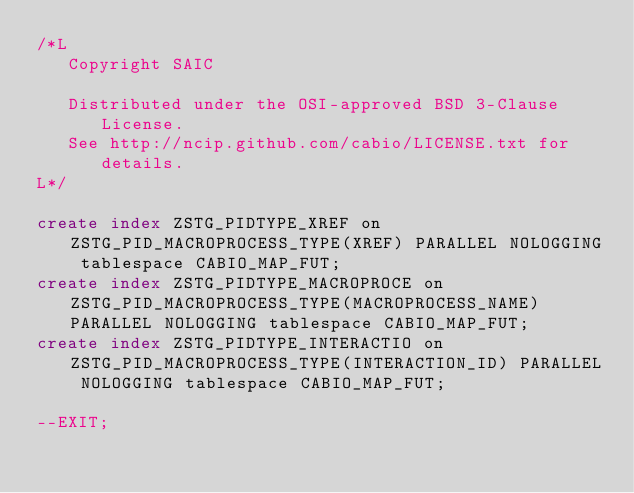Convert code to text. <code><loc_0><loc_0><loc_500><loc_500><_SQL_>/*L
   Copyright SAIC

   Distributed under the OSI-approved BSD 3-Clause License.
   See http://ncip.github.com/cabio/LICENSE.txt for details.
L*/

create index ZSTG_PIDTYPE_XREF on ZSTG_PID_MACROPROCESS_TYPE(XREF) PARALLEL NOLOGGING tablespace CABIO_MAP_FUT;
create index ZSTG_PIDTYPE_MACROPROCE on ZSTG_PID_MACROPROCESS_TYPE(MACROPROCESS_NAME) PARALLEL NOLOGGING tablespace CABIO_MAP_FUT;
create index ZSTG_PIDTYPE_INTERACTIO on ZSTG_PID_MACROPROCESS_TYPE(INTERACTION_ID) PARALLEL NOLOGGING tablespace CABIO_MAP_FUT;

--EXIT;
</code> 